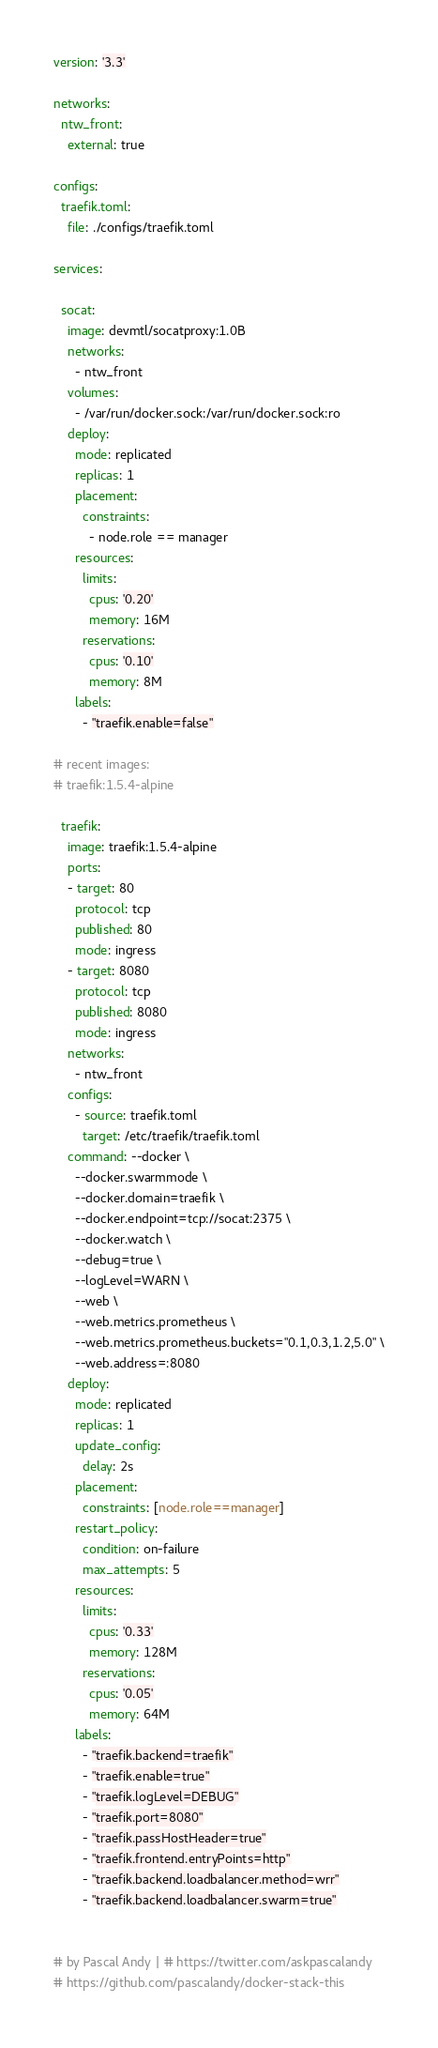Convert code to text. <code><loc_0><loc_0><loc_500><loc_500><_YAML_>version: '3.3'

networks:
  ntw_front:
    external: true

configs:
  traefik.toml:
    file: ./configs/traefik.toml

services:

  socat:
    image: devmtl/socatproxy:1.0B
    networks:
      - ntw_front
    volumes:
      - /var/run/docker.sock:/var/run/docker.sock:ro
    deploy:
      mode: replicated
      replicas: 1
      placement:
        constraints:
          - node.role == manager
      resources:
        limits:
          cpus: '0.20'
          memory: 16M
        reservations:
          cpus: '0.10'
          memory: 8M
      labels:
        - "traefik.enable=false"

# recent images:
# traefik:1.5.4-alpine

  traefik:
    image: traefik:1.5.4-alpine
    ports:
    - target: 80
      protocol: tcp
      published: 80
      mode: ingress
    - target: 8080
      protocol: tcp
      published: 8080
      mode: ingress
    networks:
      - ntw_front
    configs:
      - source: traefik.toml
        target: /etc/traefik/traefik.toml
    command: --docker \
      --docker.swarmmode \
      --docker.domain=traefik \
      --docker.endpoint=tcp://socat:2375 \
      --docker.watch \
      --debug=true \
      --logLevel=WARN \
      --web \
      --web.metrics.prometheus \
      --web.metrics.prometheus.buckets="0.1,0.3,1.2,5.0" \
      --web.address=:8080
    deploy:
      mode: replicated
      replicas: 1
      update_config:
        delay: 2s
      placement:
        constraints: [node.role==manager]
      restart_policy:
        condition: on-failure
        max_attempts: 5
      resources:
        limits:
          cpus: '0.33'
          memory: 128M
        reservations:
          cpus: '0.05'
          memory: 64M
      labels:
        - "traefik.backend=traefik"
        - "traefik.enable=true"
        - "traefik.logLevel=DEBUG"
        - "traefik.port=8080"
        - "traefik.passHostHeader=true"
        - "traefik.frontend.entryPoints=http"
        - "traefik.backend.loadbalancer.method=wrr"
        - "traefik.backend.loadbalancer.swarm=true"


# by Pascal Andy | # https://twitter.com/askpascalandy
# https://github.com/pascalandy/docker-stack-this
</code> 